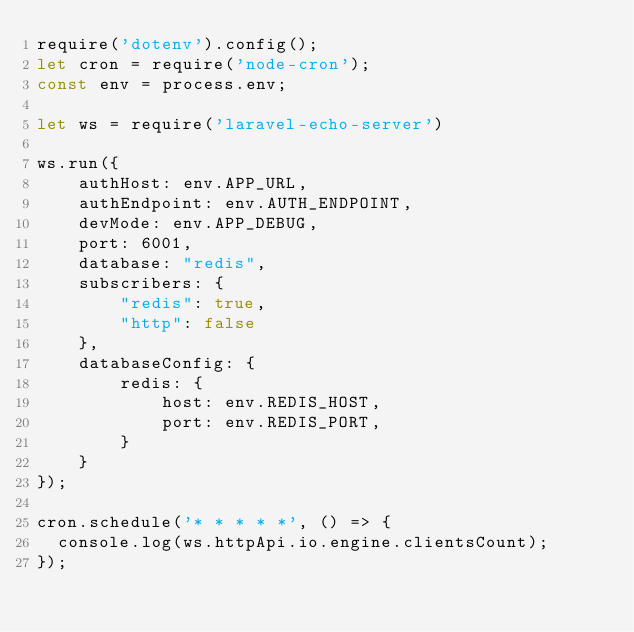<code> <loc_0><loc_0><loc_500><loc_500><_JavaScript_>require('dotenv').config();
let cron = require('node-cron');
const env = process.env;

let ws = require('laravel-echo-server')

ws.run({
    authHost: env.APP_URL,
    authEndpoint: env.AUTH_ENDPOINT,
    devMode: env.APP_DEBUG,
    port: 6001,
    database: "redis",
    subscribers: {
        "redis": true,
        "http": false
    },
    databaseConfig: {
        redis: {
            host: env.REDIS_HOST,
            port: env.REDIS_PORT,
        }
    }
});

cron.schedule('* * * * *', () => {
  console.log(ws.httpApi.io.engine.clientsCount);
});
</code> 